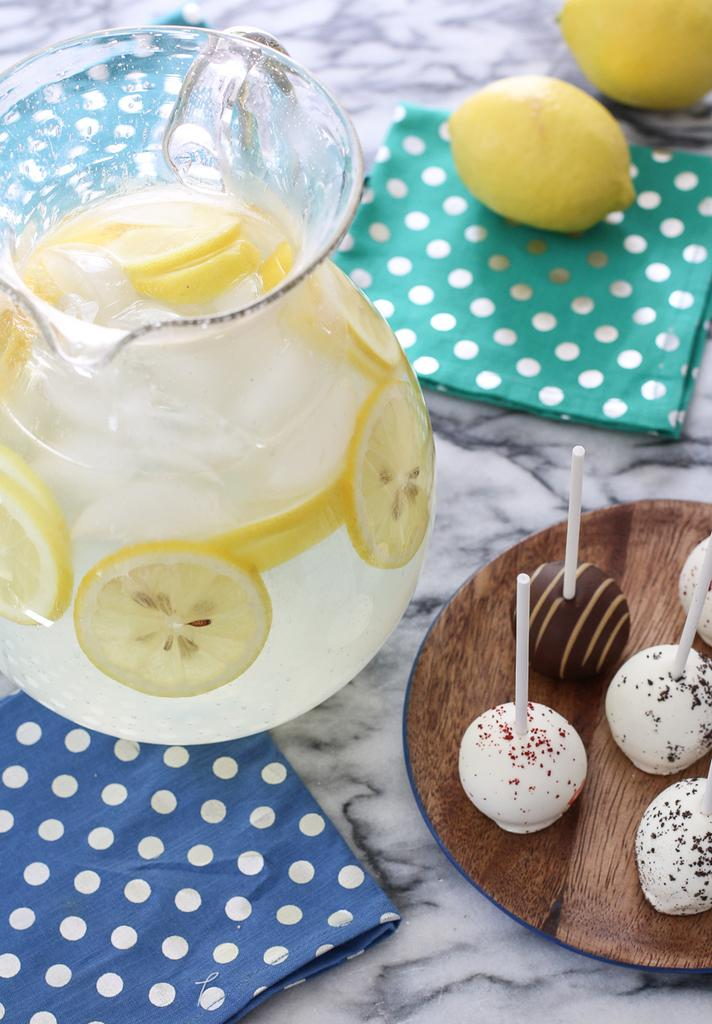What is inside the jar that is visible in the image? There is a jar with lemon slices and liquid inside it. What might be used for cleaning or wiping in the image? Napkins are visible in the image for cleaning or wiping. What type of food can be seen on the plate in the image? There is a plate with food in the image, but the specific type of food is not mentioned in the facts. What else can be seen on the surface besides the jar and plate? There are lemons placed on the surface. What type of art is being discussed in the meeting in the image? There is no meeting or art present in the image; it features a jar with lemon slices and liquid, napkins, a plate with food, and lemons on the surface. How does the stomach of the person in the image feel after eating the food on the plate? There is no information about the person's stomach or their feelings after eating the food in the image. 